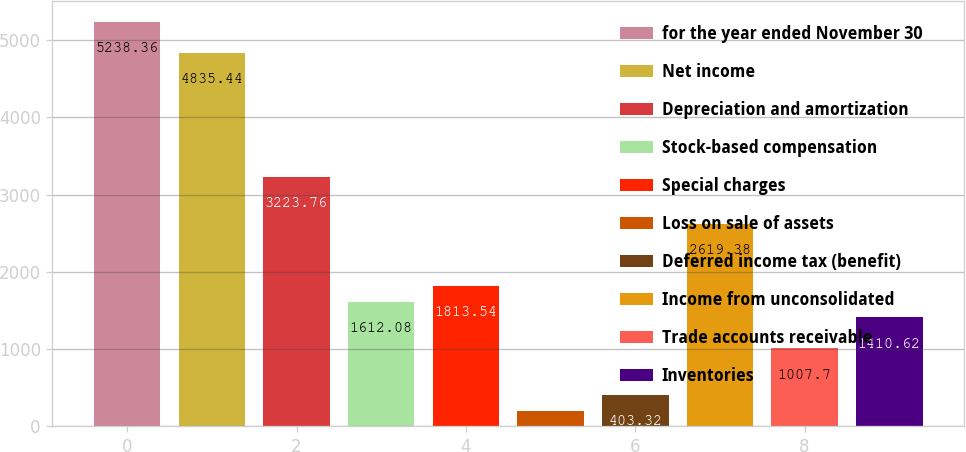<chart> <loc_0><loc_0><loc_500><loc_500><bar_chart><fcel>for the year ended November 30<fcel>Net income<fcel>Depreciation and amortization<fcel>Stock-based compensation<fcel>Special charges<fcel>Loss on sale of assets<fcel>Deferred income tax (benefit)<fcel>Income from unconsolidated<fcel>Trade accounts receivable<fcel>Inventories<nl><fcel>5238.36<fcel>4835.44<fcel>3223.76<fcel>1612.08<fcel>1813.54<fcel>201.86<fcel>403.32<fcel>2619.38<fcel>1007.7<fcel>1410.62<nl></chart> 